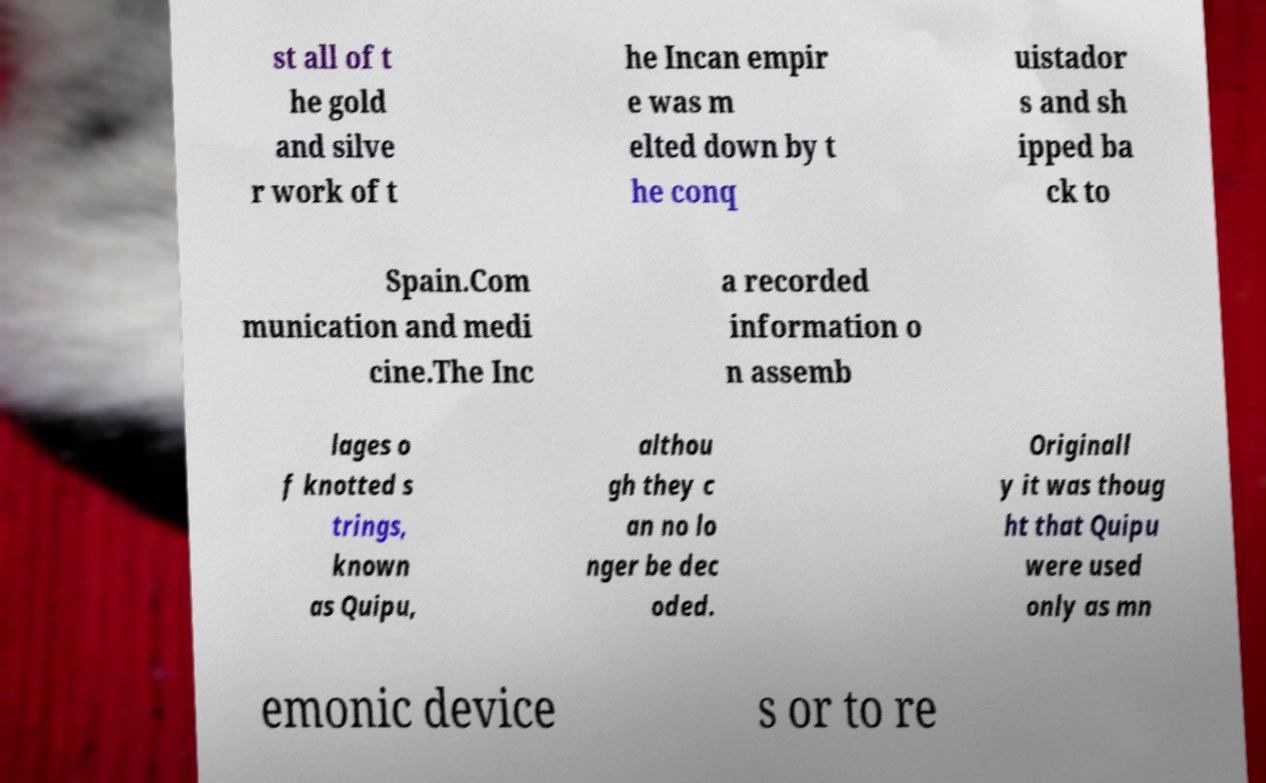There's text embedded in this image that I need extracted. Can you transcribe it verbatim? st all of t he gold and silve r work of t he Incan empir e was m elted down by t he conq uistador s and sh ipped ba ck to Spain.Com munication and medi cine.The Inc a recorded information o n assemb lages o f knotted s trings, known as Quipu, althou gh they c an no lo nger be dec oded. Originall y it was thoug ht that Quipu were used only as mn emonic device s or to re 